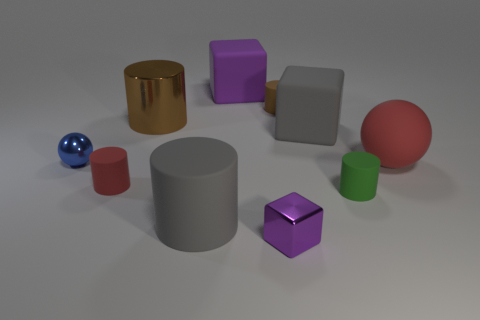Subtract all balls. How many objects are left? 8 Subtract 0 green blocks. How many objects are left? 10 Subtract all tiny balls. Subtract all large gray matte objects. How many objects are left? 7 Add 1 small green rubber cylinders. How many small green rubber cylinders are left? 2 Add 6 big red cylinders. How many big red cylinders exist? 6 